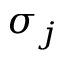Convert formula to latex. <formula><loc_0><loc_0><loc_500><loc_500>\sigma _ { j }</formula> 